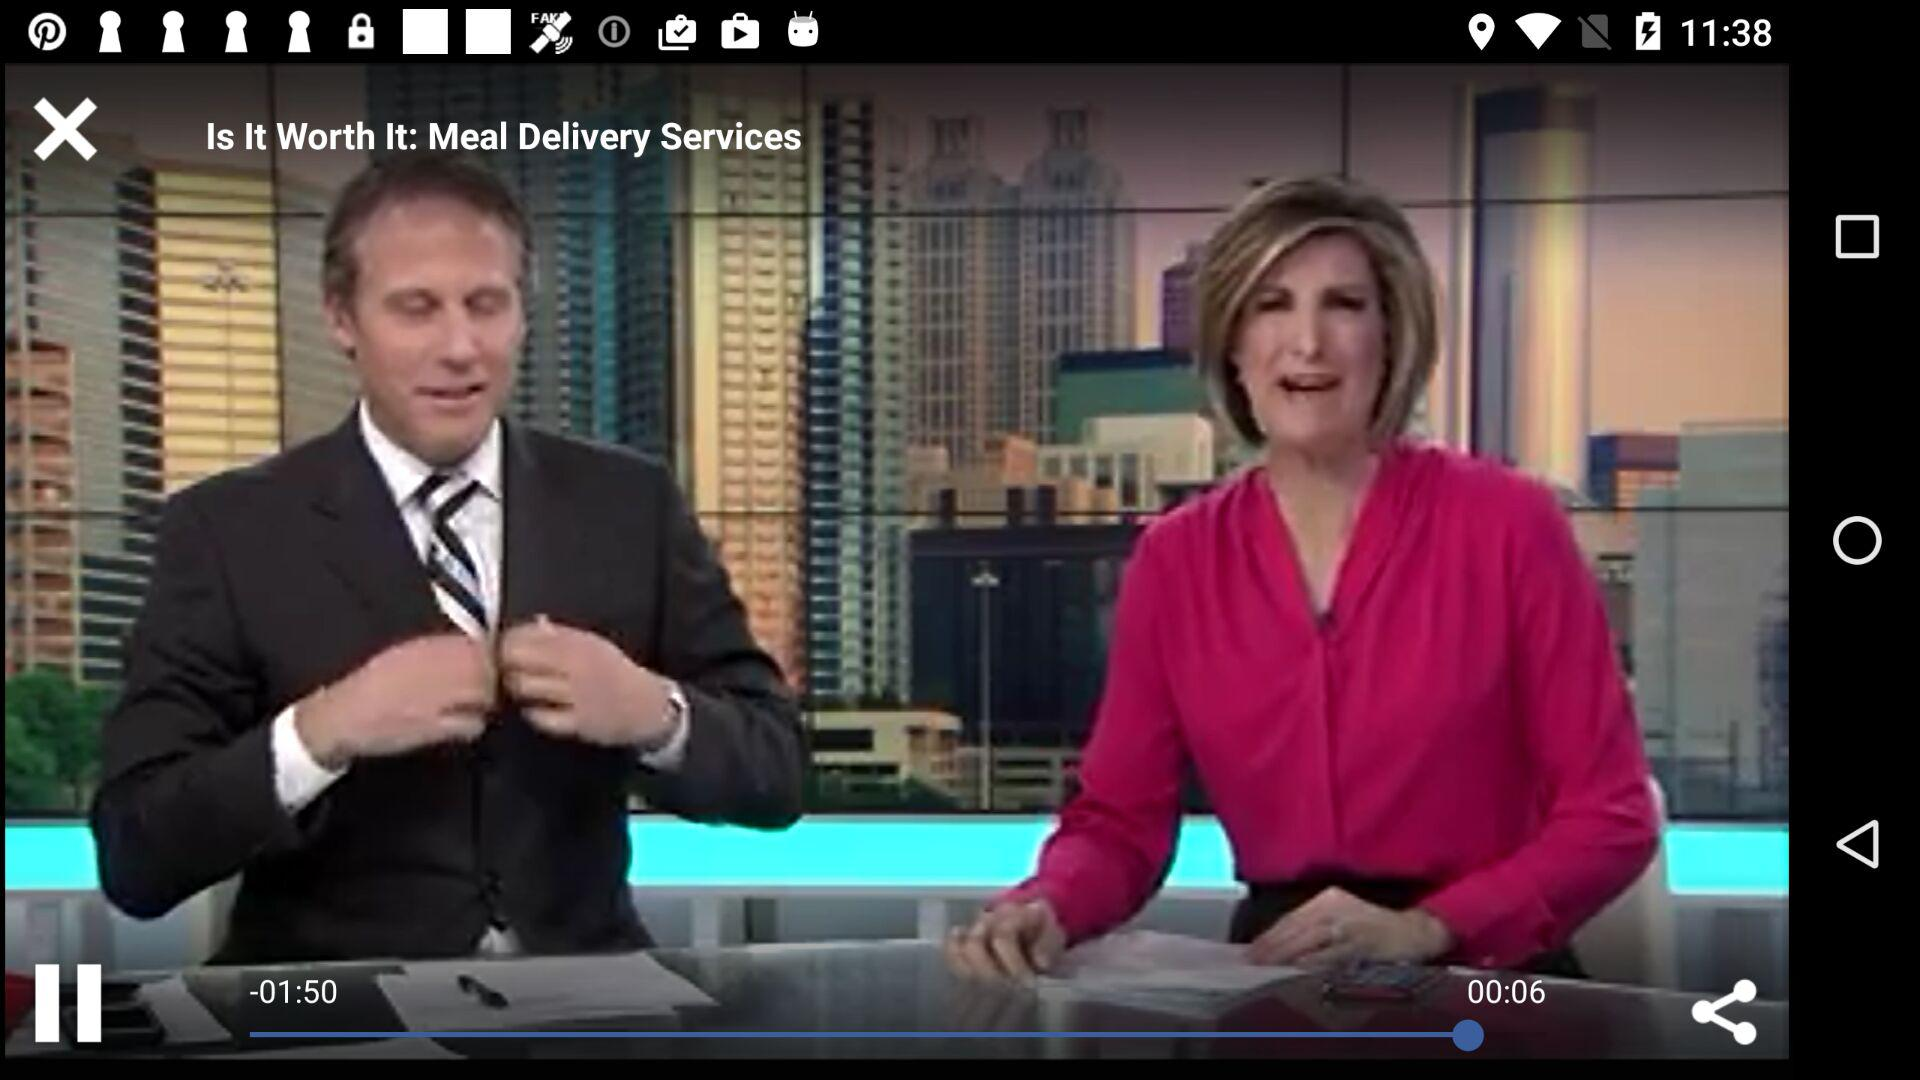What date is displayed on the screen? The displayed date is 2/10/2017. 